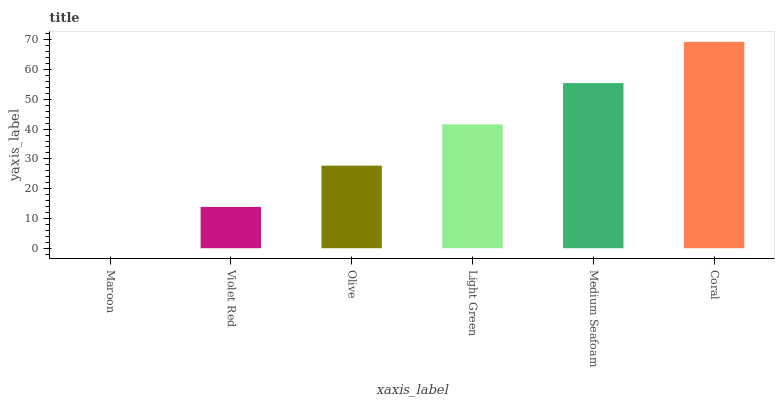Is Maroon the minimum?
Answer yes or no. Yes. Is Coral the maximum?
Answer yes or no. Yes. Is Violet Red the minimum?
Answer yes or no. No. Is Violet Red the maximum?
Answer yes or no. No. Is Violet Red greater than Maroon?
Answer yes or no. Yes. Is Maroon less than Violet Red?
Answer yes or no. Yes. Is Maroon greater than Violet Red?
Answer yes or no. No. Is Violet Red less than Maroon?
Answer yes or no. No. Is Light Green the high median?
Answer yes or no. Yes. Is Olive the low median?
Answer yes or no. Yes. Is Coral the high median?
Answer yes or no. No. Is Violet Red the low median?
Answer yes or no. No. 